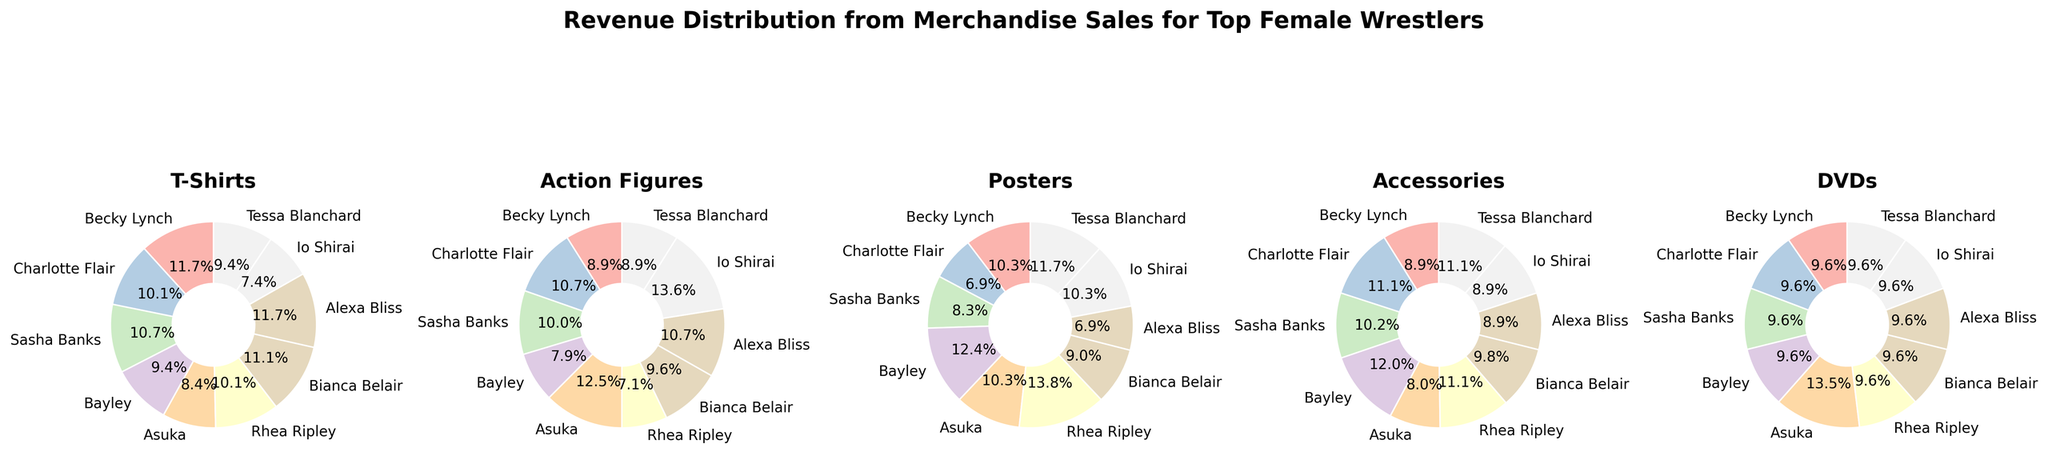Which wrestler has the highest revenue share from Action Figures? Tessa Blanchard, Io Shirai, and Asuka all appear to have a high revenue share from Action Figures. By visual inspection, Asuka's wedge slice appears largest.
Answer: Asuka Which wrestler has the smallest slice in T-Shirts? By looking at the pie chart for T-Shirts, Io Shirai has the smallest slice.
Answer: Io Shirai Which merchandise category has the most evenly distributed shares among wrestlers? Look at the pie charts and see how evenly the slices are distributed. Accessories have fairly equal slices among the wrestlers.
Answer: Accessories Compare the revenue share from Posters for Bayley and Rhea Ripley. Which one is higher? Look at the Poster pie chart and compare the slices for Bayley and Rhea Ripley. Bayley's segment is larger than Rhea Ripley's.
Answer: Bayley What's the combined share of revenue from DVDs for all wrestlers? The pie charts for DVDs show five segments for different wrestlers, and each has a 10% share. Multiply and add them (10% * 10)% = 100%.
Answer: 100% Who has the largest slice in T-Shirts and Accessories categories? Inspect both the T-Shirts and Accessories pie charts. For T-Shirts, Becky Lynch and Alexa Bliss have the largest slices. For Accessories, Bayley has the largest slice.
Answer: Becky Lynch, Alexa Bliss, and Bayley Which wrestler has a higher revenue share from T-Shirts, Becky Lynch or Charlotte Flair? Look at the T-Shirts pie chart and compare Becky Lynch's and Charlotte Flair's shares. Becky Lynch's slice is larger.
Answer: Becky Lynch Is the revenue share from DVDs equal for all the wrestlers? All slices in the DVDs pie chart are of equal size.
Answer: Yes How does Sasha Banks' revenue share from Posters compare to Asuka's? Looking at the Posters pie chart, compare the slices for Sasha Banks and Asuka. Sasha Banks' slice is slightly larger.
Answer: Sasha Banks Which merchandise category seems to have the least variation in revenue share among wrestlers? By glancing at all pie charts, DVDs has equal slices for all wrestlers, indicating the least variation.
Answer: DVDs 